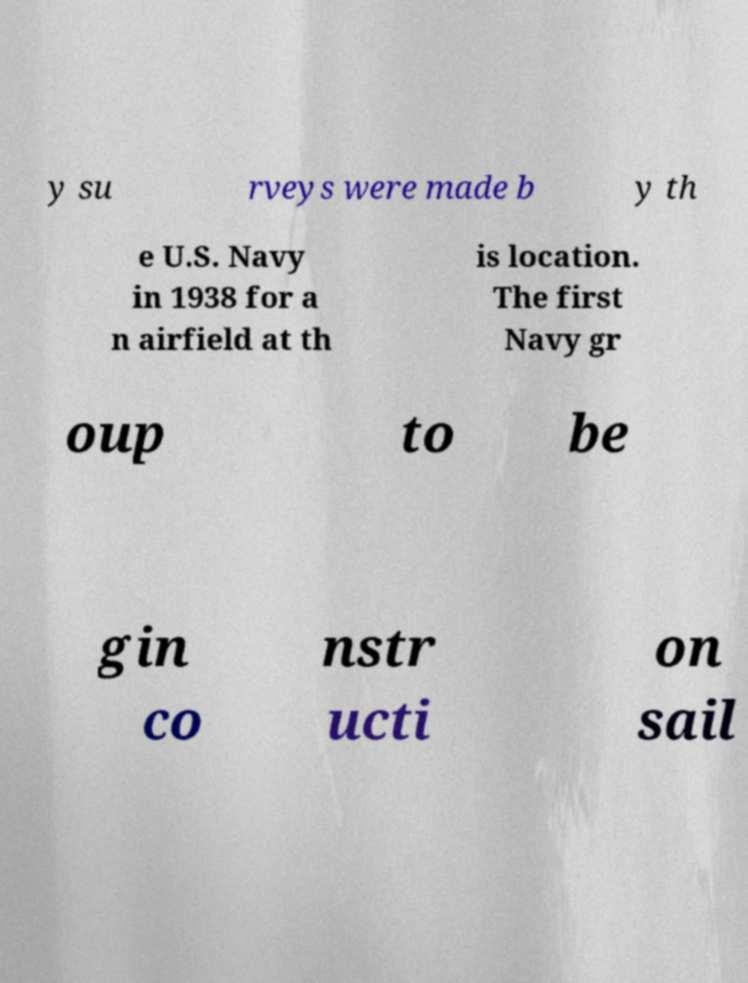I need the written content from this picture converted into text. Can you do that? y su rveys were made b y th e U.S. Navy in 1938 for a n airfield at th is location. The first Navy gr oup to be gin co nstr ucti on sail 